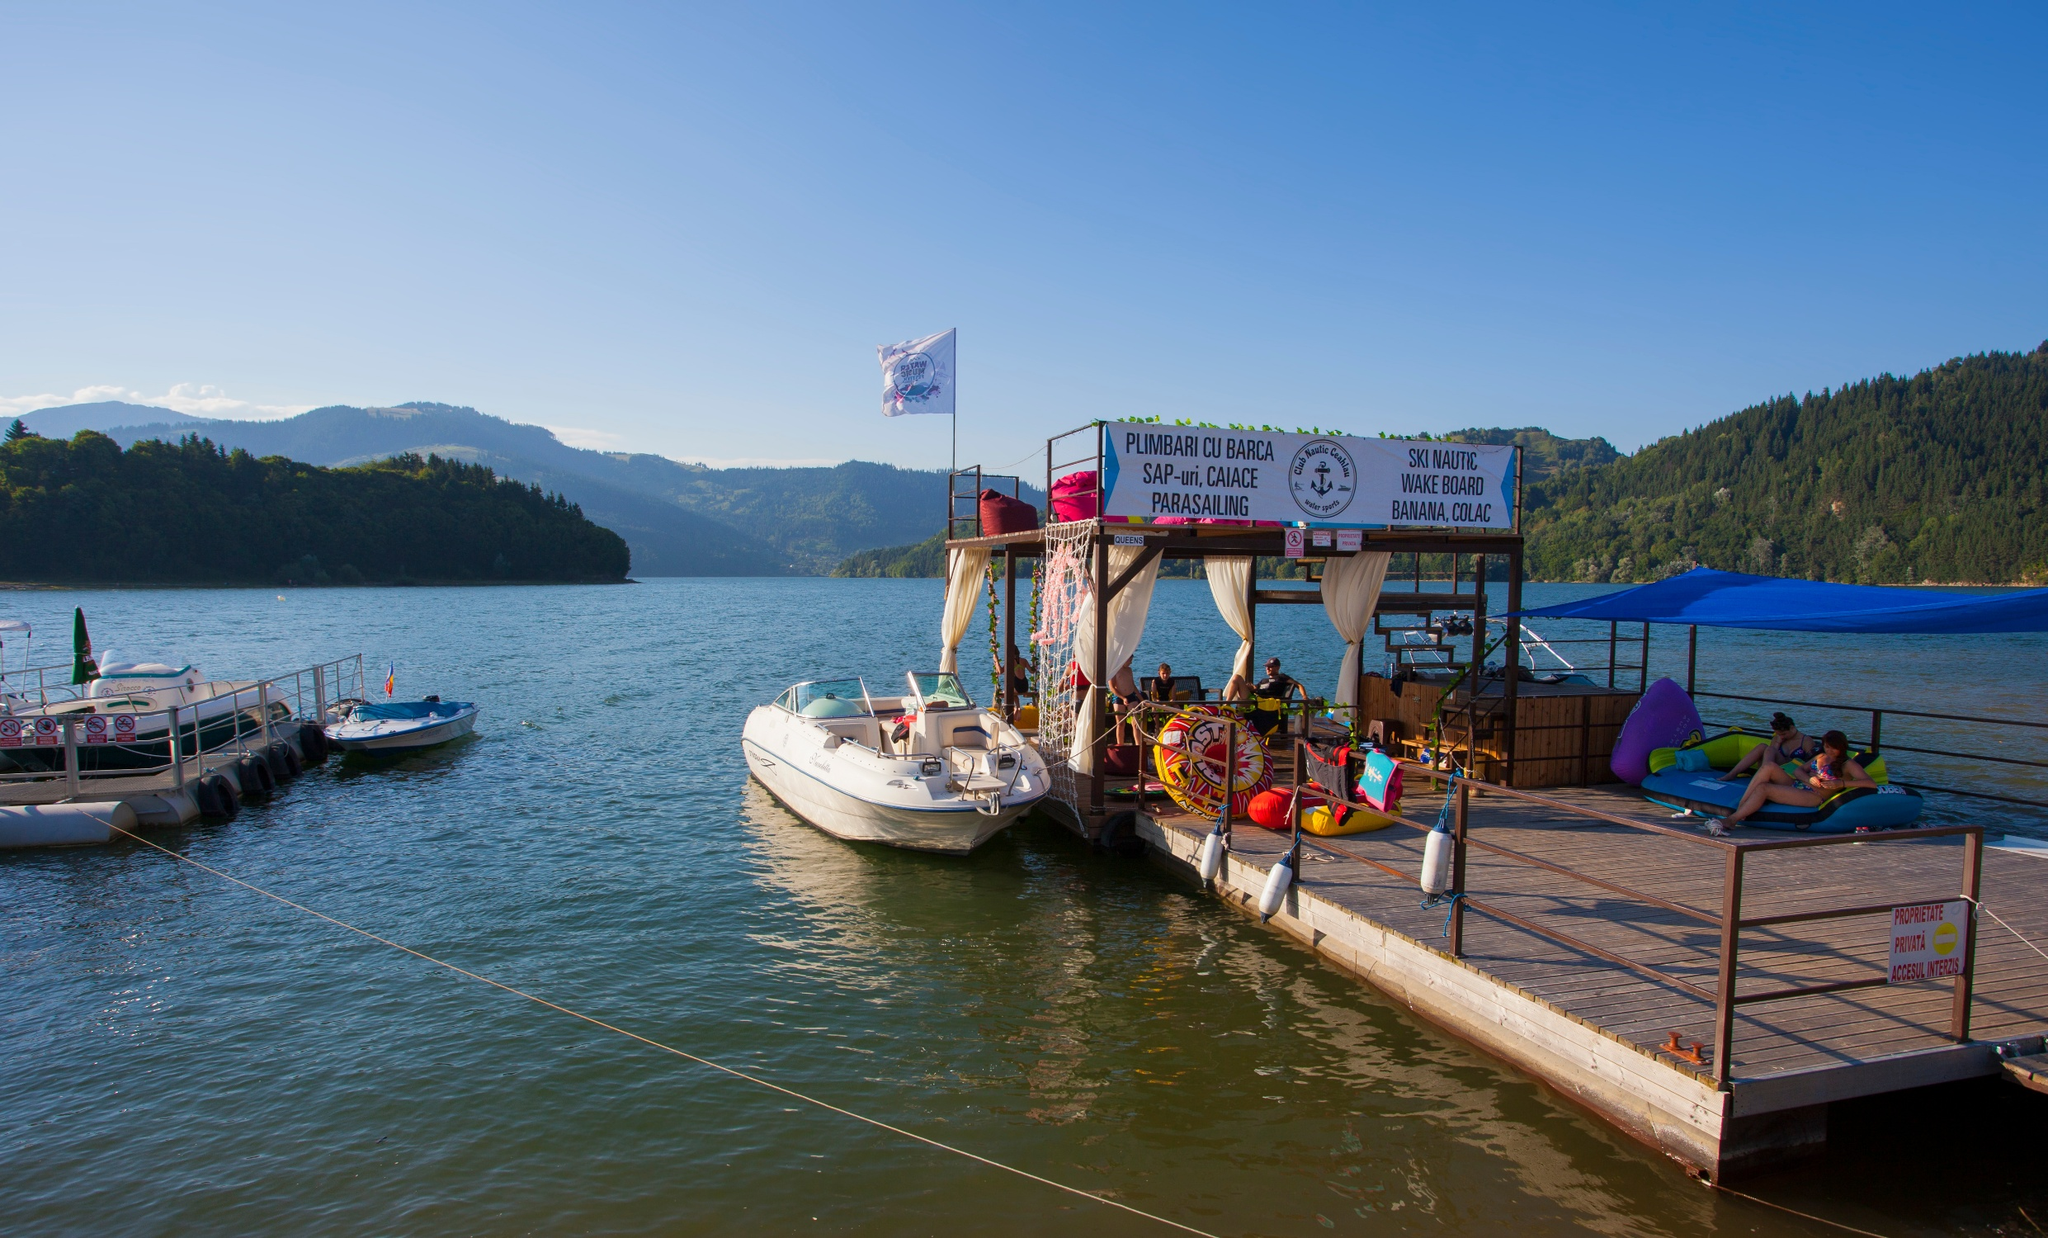What do you see happening in this image? The image captures a serene lakeside scene. A small wooden dock extends into the calm water, with a few boats moored alongside. At the end of the dock, a colorful shack stands out, its sign reading "Pulperia La Boca" and "Snack Bar Masque". Above the shack, a small American flag flutters in the breeze, adding a touch of patriotism to the scene. The lake itself is nestled amidst lush green hills and towering mountains, creating a picturesque backdrop. The sky overhead is a clear blue, reflecting lightly on the tranquil water surface. The perspective of the image is from the shore, looking out onto the lake, inviting viewers to imagine themselves stepping onto the dock and drifting away on one of the boats. The landmark identifier "sa_1273" doesn't provide additional information about the location of this peaceful setting. 